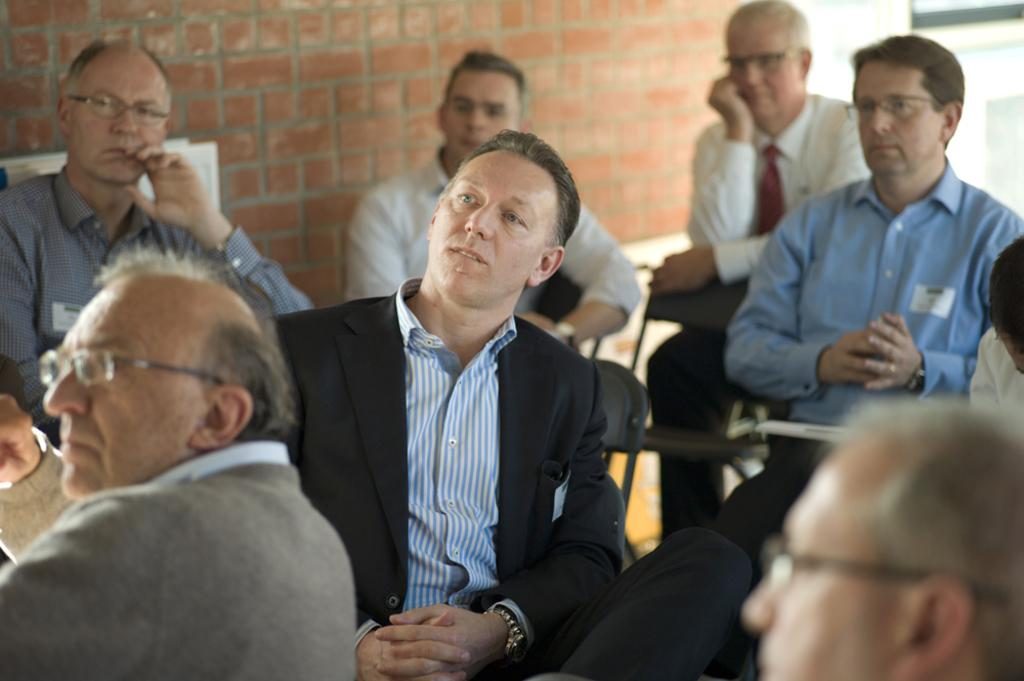What are the people in the image doing? The people in the image are sitting on chairs. Can you describe the appearance of one of the individuals in the image? A man at the left bottom of the image is wearing spectacles. What can be seen in the background of the image? There is a brick wall in the background of the image. What type of zinc object is being used by the people in the image? There is no zinc object present in the image. How does the earthquake affect the people sitting on chairs in the image? There is no earthquake depicted in the image, so its effects cannot be determined. 